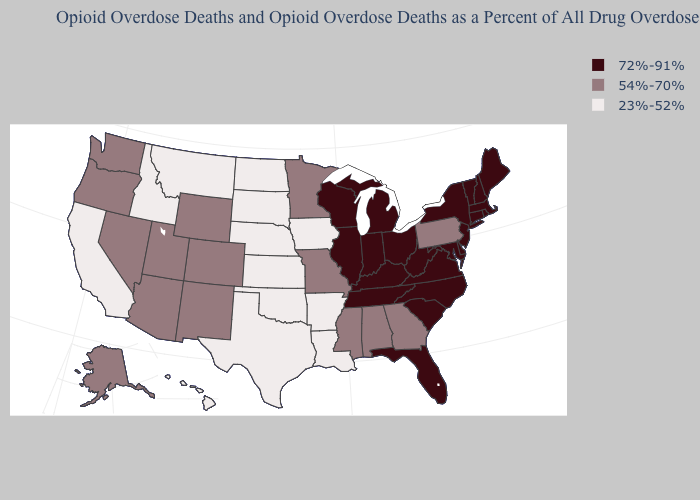What is the value of New Jersey?
Answer briefly. 72%-91%. Which states have the lowest value in the MidWest?
Answer briefly. Iowa, Kansas, Nebraska, North Dakota, South Dakota. Does the map have missing data?
Write a very short answer. No. Does South Carolina have the same value as Indiana?
Write a very short answer. Yes. What is the value of West Virginia?
Give a very brief answer. 72%-91%. Does the map have missing data?
Give a very brief answer. No. Which states hav the highest value in the South?
Give a very brief answer. Delaware, Florida, Kentucky, Maryland, North Carolina, South Carolina, Tennessee, Virginia, West Virginia. Among the states that border Delaware , does Pennsylvania have the highest value?
Be succinct. No. Among the states that border Oregon , which have the lowest value?
Give a very brief answer. California, Idaho. What is the value of North Carolina?
Quick response, please. 72%-91%. Does Ohio have the highest value in the MidWest?
Quick response, please. Yes. What is the lowest value in the USA?
Quick response, please. 23%-52%. Does the map have missing data?
Short answer required. No. Does the first symbol in the legend represent the smallest category?
Concise answer only. No. Does Pennsylvania have the highest value in the USA?
Answer briefly. No. 